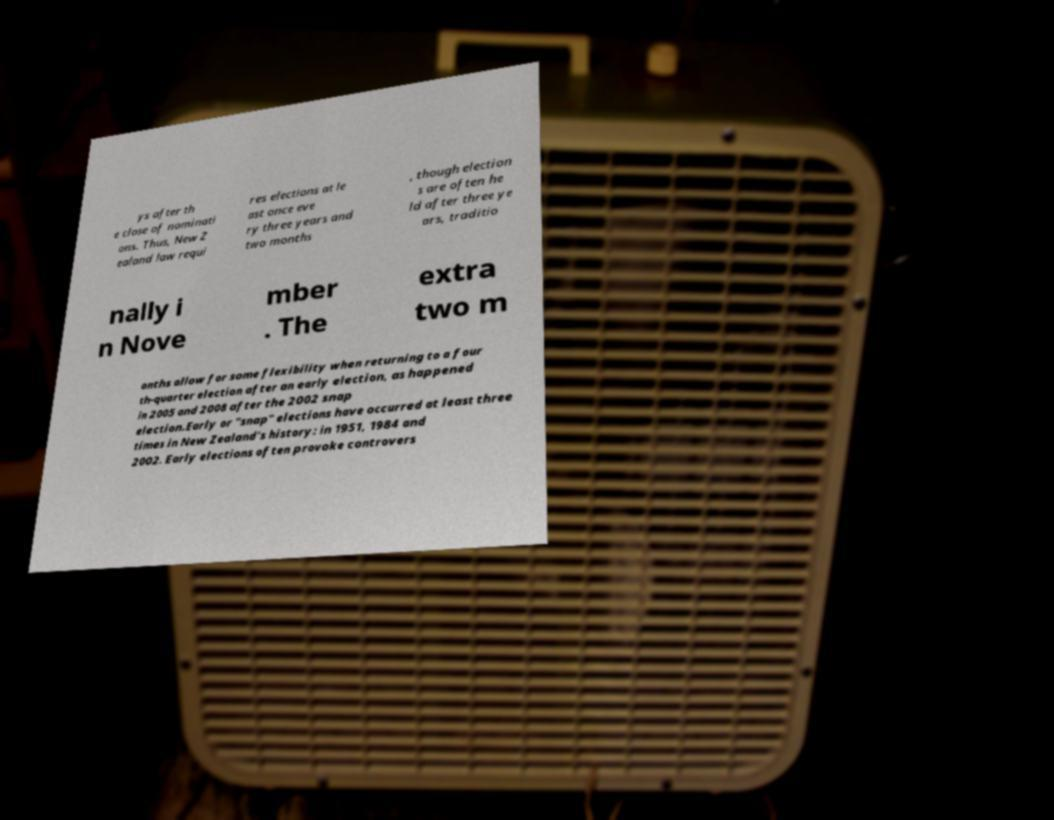Please read and relay the text visible in this image. What does it say? ys after th e close of nominati ons. Thus, New Z ealand law requi res elections at le ast once eve ry three years and two months , though election s are often he ld after three ye ars, traditio nally i n Nove mber . The extra two m onths allow for some flexibility when returning to a four th-quarter election after an early election, as happened in 2005 and 2008 after the 2002 snap election.Early or "snap" elections have occurred at least three times in New Zealand's history: in 1951, 1984 and 2002. Early elections often provoke controvers 